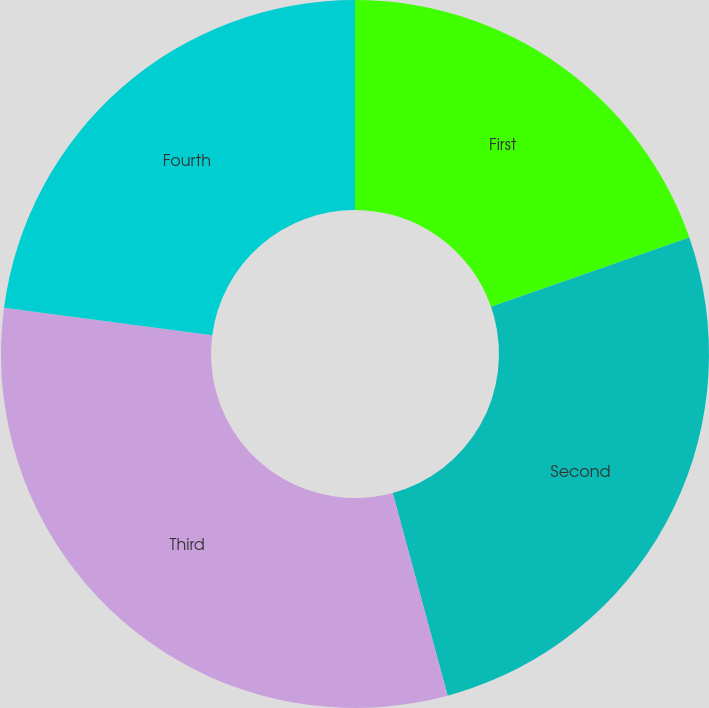Convert chart to OTSL. <chart><loc_0><loc_0><loc_500><loc_500><pie_chart><fcel>First<fcel>Second<fcel>Third<fcel>Fourth<nl><fcel>19.67%<fcel>26.12%<fcel>31.3%<fcel>22.92%<nl></chart> 